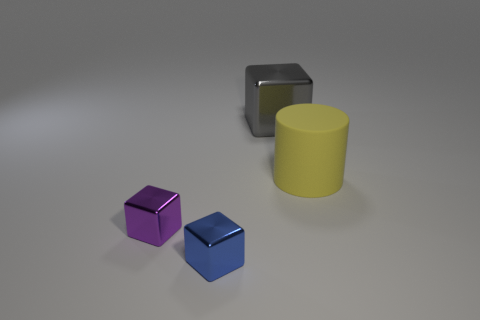Add 3 blue metal cubes. How many objects exist? 7 Subtract all cylinders. How many objects are left? 3 Subtract all big brown rubber cubes. Subtract all large objects. How many objects are left? 2 Add 1 large matte objects. How many large matte objects are left? 2 Add 4 tiny purple shiny cubes. How many tiny purple shiny cubes exist? 5 Subtract 0 green cubes. How many objects are left? 4 